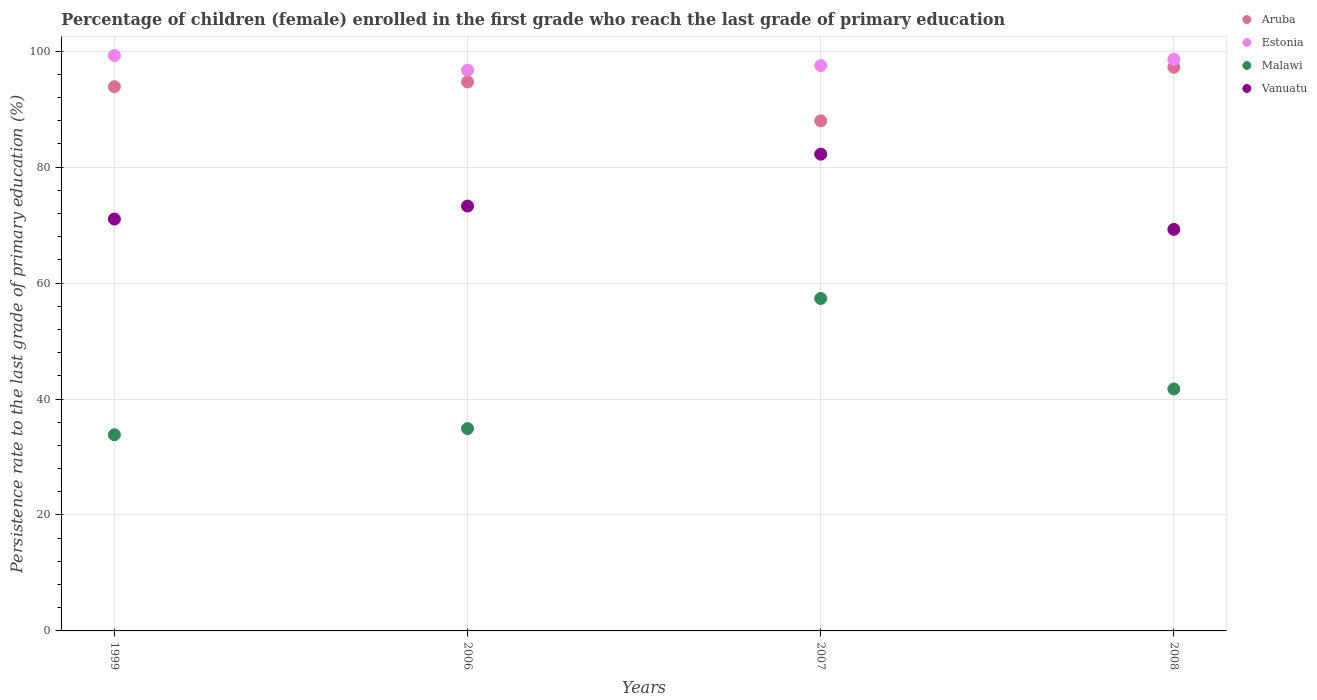What is the persistence rate of children in Estonia in 2006?
Make the answer very short. 96.73. Across all years, what is the maximum persistence rate of children in Aruba?
Give a very brief answer. 97.23. Across all years, what is the minimum persistence rate of children in Malawi?
Provide a succinct answer. 33.84. What is the total persistence rate of children in Aruba in the graph?
Offer a very short reply. 373.79. What is the difference between the persistence rate of children in Vanuatu in 2007 and that in 2008?
Provide a succinct answer. 12.98. What is the difference between the persistence rate of children in Malawi in 1999 and the persistence rate of children in Aruba in 2007?
Offer a terse response. -54.15. What is the average persistence rate of children in Estonia per year?
Ensure brevity in your answer.  98.03. In the year 2006, what is the difference between the persistence rate of children in Estonia and persistence rate of children in Malawi?
Keep it short and to the point. 61.83. In how many years, is the persistence rate of children in Estonia greater than 32 %?
Your answer should be compact. 4. What is the ratio of the persistence rate of children in Estonia in 2006 to that in 2007?
Provide a succinct answer. 0.99. Is the persistence rate of children in Vanuatu in 1999 less than that in 2007?
Keep it short and to the point. Yes. What is the difference between the highest and the second highest persistence rate of children in Malawi?
Ensure brevity in your answer.  15.61. What is the difference between the highest and the lowest persistence rate of children in Estonia?
Give a very brief answer. 2.52. In how many years, is the persistence rate of children in Malawi greater than the average persistence rate of children in Malawi taken over all years?
Provide a short and direct response. 1. Is the sum of the persistence rate of children in Aruba in 2007 and 2008 greater than the maximum persistence rate of children in Malawi across all years?
Provide a short and direct response. Yes. Is it the case that in every year, the sum of the persistence rate of children in Estonia and persistence rate of children in Vanuatu  is greater than the sum of persistence rate of children in Aruba and persistence rate of children in Malawi?
Provide a short and direct response. Yes. Is the persistence rate of children in Aruba strictly greater than the persistence rate of children in Estonia over the years?
Your answer should be compact. No. What is the difference between two consecutive major ticks on the Y-axis?
Offer a very short reply. 20. Does the graph contain any zero values?
Your answer should be compact. No. Where does the legend appear in the graph?
Offer a terse response. Top right. How are the legend labels stacked?
Your response must be concise. Vertical. What is the title of the graph?
Offer a very short reply. Percentage of children (female) enrolled in the first grade who reach the last grade of primary education. Does "Middle East & North Africa (developing only)" appear as one of the legend labels in the graph?
Make the answer very short. No. What is the label or title of the Y-axis?
Ensure brevity in your answer.  Persistence rate to the last grade of primary education (%). What is the Persistence rate to the last grade of primary education (%) of Aruba in 1999?
Your response must be concise. 93.88. What is the Persistence rate to the last grade of primary education (%) of Estonia in 1999?
Ensure brevity in your answer.  99.25. What is the Persistence rate to the last grade of primary education (%) of Malawi in 1999?
Your answer should be compact. 33.84. What is the Persistence rate to the last grade of primary education (%) of Vanuatu in 1999?
Offer a terse response. 71.05. What is the Persistence rate to the last grade of primary education (%) in Aruba in 2006?
Make the answer very short. 94.7. What is the Persistence rate to the last grade of primary education (%) of Estonia in 2006?
Your answer should be very brief. 96.73. What is the Persistence rate to the last grade of primary education (%) of Malawi in 2006?
Your response must be concise. 34.9. What is the Persistence rate to the last grade of primary education (%) in Vanuatu in 2006?
Your answer should be very brief. 73.29. What is the Persistence rate to the last grade of primary education (%) in Aruba in 2007?
Your response must be concise. 87.99. What is the Persistence rate to the last grade of primary education (%) in Estonia in 2007?
Your answer should be very brief. 97.52. What is the Persistence rate to the last grade of primary education (%) of Malawi in 2007?
Ensure brevity in your answer.  57.35. What is the Persistence rate to the last grade of primary education (%) of Vanuatu in 2007?
Provide a short and direct response. 82.24. What is the Persistence rate to the last grade of primary education (%) in Aruba in 2008?
Offer a very short reply. 97.23. What is the Persistence rate to the last grade of primary education (%) in Estonia in 2008?
Offer a very short reply. 98.6. What is the Persistence rate to the last grade of primary education (%) in Malawi in 2008?
Your response must be concise. 41.74. What is the Persistence rate to the last grade of primary education (%) of Vanuatu in 2008?
Provide a short and direct response. 69.26. Across all years, what is the maximum Persistence rate to the last grade of primary education (%) in Aruba?
Give a very brief answer. 97.23. Across all years, what is the maximum Persistence rate to the last grade of primary education (%) of Estonia?
Offer a terse response. 99.25. Across all years, what is the maximum Persistence rate to the last grade of primary education (%) of Malawi?
Keep it short and to the point. 57.35. Across all years, what is the maximum Persistence rate to the last grade of primary education (%) in Vanuatu?
Your response must be concise. 82.24. Across all years, what is the minimum Persistence rate to the last grade of primary education (%) in Aruba?
Offer a very short reply. 87.99. Across all years, what is the minimum Persistence rate to the last grade of primary education (%) in Estonia?
Your answer should be very brief. 96.73. Across all years, what is the minimum Persistence rate to the last grade of primary education (%) of Malawi?
Provide a short and direct response. 33.84. Across all years, what is the minimum Persistence rate to the last grade of primary education (%) of Vanuatu?
Ensure brevity in your answer.  69.26. What is the total Persistence rate to the last grade of primary education (%) in Aruba in the graph?
Offer a very short reply. 373.79. What is the total Persistence rate to the last grade of primary education (%) of Estonia in the graph?
Provide a succinct answer. 392.11. What is the total Persistence rate to the last grade of primary education (%) of Malawi in the graph?
Provide a succinct answer. 167.82. What is the total Persistence rate to the last grade of primary education (%) of Vanuatu in the graph?
Ensure brevity in your answer.  295.84. What is the difference between the Persistence rate to the last grade of primary education (%) in Aruba in 1999 and that in 2006?
Provide a succinct answer. -0.82. What is the difference between the Persistence rate to the last grade of primary education (%) of Estonia in 1999 and that in 2006?
Provide a succinct answer. 2.52. What is the difference between the Persistence rate to the last grade of primary education (%) in Malawi in 1999 and that in 2006?
Offer a terse response. -1.06. What is the difference between the Persistence rate to the last grade of primary education (%) in Vanuatu in 1999 and that in 2006?
Offer a very short reply. -2.25. What is the difference between the Persistence rate to the last grade of primary education (%) in Aruba in 1999 and that in 2007?
Offer a very short reply. 5.89. What is the difference between the Persistence rate to the last grade of primary education (%) of Estonia in 1999 and that in 2007?
Keep it short and to the point. 1.73. What is the difference between the Persistence rate to the last grade of primary education (%) of Malawi in 1999 and that in 2007?
Ensure brevity in your answer.  -23.51. What is the difference between the Persistence rate to the last grade of primary education (%) of Vanuatu in 1999 and that in 2007?
Provide a succinct answer. -11.19. What is the difference between the Persistence rate to the last grade of primary education (%) in Aruba in 1999 and that in 2008?
Give a very brief answer. -3.35. What is the difference between the Persistence rate to the last grade of primary education (%) of Estonia in 1999 and that in 2008?
Your response must be concise. 0.65. What is the difference between the Persistence rate to the last grade of primary education (%) in Vanuatu in 1999 and that in 2008?
Your answer should be very brief. 1.79. What is the difference between the Persistence rate to the last grade of primary education (%) in Aruba in 2006 and that in 2007?
Give a very brief answer. 6.71. What is the difference between the Persistence rate to the last grade of primary education (%) in Estonia in 2006 and that in 2007?
Your answer should be very brief. -0.79. What is the difference between the Persistence rate to the last grade of primary education (%) of Malawi in 2006 and that in 2007?
Give a very brief answer. -22.45. What is the difference between the Persistence rate to the last grade of primary education (%) of Vanuatu in 2006 and that in 2007?
Keep it short and to the point. -8.94. What is the difference between the Persistence rate to the last grade of primary education (%) of Aruba in 2006 and that in 2008?
Provide a short and direct response. -2.54. What is the difference between the Persistence rate to the last grade of primary education (%) of Estonia in 2006 and that in 2008?
Your response must be concise. -1.87. What is the difference between the Persistence rate to the last grade of primary education (%) in Malawi in 2006 and that in 2008?
Your answer should be very brief. -6.84. What is the difference between the Persistence rate to the last grade of primary education (%) in Vanuatu in 2006 and that in 2008?
Keep it short and to the point. 4.03. What is the difference between the Persistence rate to the last grade of primary education (%) in Aruba in 2007 and that in 2008?
Provide a succinct answer. -9.24. What is the difference between the Persistence rate to the last grade of primary education (%) of Estonia in 2007 and that in 2008?
Make the answer very short. -1.08. What is the difference between the Persistence rate to the last grade of primary education (%) of Malawi in 2007 and that in 2008?
Give a very brief answer. 15.61. What is the difference between the Persistence rate to the last grade of primary education (%) in Vanuatu in 2007 and that in 2008?
Provide a succinct answer. 12.98. What is the difference between the Persistence rate to the last grade of primary education (%) in Aruba in 1999 and the Persistence rate to the last grade of primary education (%) in Estonia in 2006?
Make the answer very short. -2.85. What is the difference between the Persistence rate to the last grade of primary education (%) of Aruba in 1999 and the Persistence rate to the last grade of primary education (%) of Malawi in 2006?
Your response must be concise. 58.98. What is the difference between the Persistence rate to the last grade of primary education (%) in Aruba in 1999 and the Persistence rate to the last grade of primary education (%) in Vanuatu in 2006?
Your answer should be compact. 20.58. What is the difference between the Persistence rate to the last grade of primary education (%) of Estonia in 1999 and the Persistence rate to the last grade of primary education (%) of Malawi in 2006?
Your response must be concise. 64.35. What is the difference between the Persistence rate to the last grade of primary education (%) of Estonia in 1999 and the Persistence rate to the last grade of primary education (%) of Vanuatu in 2006?
Offer a very short reply. 25.96. What is the difference between the Persistence rate to the last grade of primary education (%) in Malawi in 1999 and the Persistence rate to the last grade of primary education (%) in Vanuatu in 2006?
Ensure brevity in your answer.  -39.46. What is the difference between the Persistence rate to the last grade of primary education (%) of Aruba in 1999 and the Persistence rate to the last grade of primary education (%) of Estonia in 2007?
Give a very brief answer. -3.65. What is the difference between the Persistence rate to the last grade of primary education (%) of Aruba in 1999 and the Persistence rate to the last grade of primary education (%) of Malawi in 2007?
Offer a terse response. 36.53. What is the difference between the Persistence rate to the last grade of primary education (%) in Aruba in 1999 and the Persistence rate to the last grade of primary education (%) in Vanuatu in 2007?
Your answer should be compact. 11.64. What is the difference between the Persistence rate to the last grade of primary education (%) of Estonia in 1999 and the Persistence rate to the last grade of primary education (%) of Malawi in 2007?
Keep it short and to the point. 41.9. What is the difference between the Persistence rate to the last grade of primary education (%) in Estonia in 1999 and the Persistence rate to the last grade of primary education (%) in Vanuatu in 2007?
Provide a short and direct response. 17.02. What is the difference between the Persistence rate to the last grade of primary education (%) in Malawi in 1999 and the Persistence rate to the last grade of primary education (%) in Vanuatu in 2007?
Provide a succinct answer. -48.4. What is the difference between the Persistence rate to the last grade of primary education (%) of Aruba in 1999 and the Persistence rate to the last grade of primary education (%) of Estonia in 2008?
Ensure brevity in your answer.  -4.72. What is the difference between the Persistence rate to the last grade of primary education (%) in Aruba in 1999 and the Persistence rate to the last grade of primary education (%) in Malawi in 2008?
Offer a very short reply. 52.14. What is the difference between the Persistence rate to the last grade of primary education (%) in Aruba in 1999 and the Persistence rate to the last grade of primary education (%) in Vanuatu in 2008?
Give a very brief answer. 24.61. What is the difference between the Persistence rate to the last grade of primary education (%) of Estonia in 1999 and the Persistence rate to the last grade of primary education (%) of Malawi in 2008?
Give a very brief answer. 57.52. What is the difference between the Persistence rate to the last grade of primary education (%) of Estonia in 1999 and the Persistence rate to the last grade of primary education (%) of Vanuatu in 2008?
Your response must be concise. 29.99. What is the difference between the Persistence rate to the last grade of primary education (%) of Malawi in 1999 and the Persistence rate to the last grade of primary education (%) of Vanuatu in 2008?
Your answer should be very brief. -35.43. What is the difference between the Persistence rate to the last grade of primary education (%) in Aruba in 2006 and the Persistence rate to the last grade of primary education (%) in Estonia in 2007?
Your answer should be very brief. -2.83. What is the difference between the Persistence rate to the last grade of primary education (%) of Aruba in 2006 and the Persistence rate to the last grade of primary education (%) of Malawi in 2007?
Offer a very short reply. 37.35. What is the difference between the Persistence rate to the last grade of primary education (%) of Aruba in 2006 and the Persistence rate to the last grade of primary education (%) of Vanuatu in 2007?
Your answer should be very brief. 12.46. What is the difference between the Persistence rate to the last grade of primary education (%) in Estonia in 2006 and the Persistence rate to the last grade of primary education (%) in Malawi in 2007?
Ensure brevity in your answer.  39.38. What is the difference between the Persistence rate to the last grade of primary education (%) in Estonia in 2006 and the Persistence rate to the last grade of primary education (%) in Vanuatu in 2007?
Give a very brief answer. 14.49. What is the difference between the Persistence rate to the last grade of primary education (%) of Malawi in 2006 and the Persistence rate to the last grade of primary education (%) of Vanuatu in 2007?
Give a very brief answer. -47.34. What is the difference between the Persistence rate to the last grade of primary education (%) in Aruba in 2006 and the Persistence rate to the last grade of primary education (%) in Estonia in 2008?
Offer a very short reply. -3.91. What is the difference between the Persistence rate to the last grade of primary education (%) of Aruba in 2006 and the Persistence rate to the last grade of primary education (%) of Malawi in 2008?
Provide a succinct answer. 52.96. What is the difference between the Persistence rate to the last grade of primary education (%) in Aruba in 2006 and the Persistence rate to the last grade of primary education (%) in Vanuatu in 2008?
Keep it short and to the point. 25.43. What is the difference between the Persistence rate to the last grade of primary education (%) of Estonia in 2006 and the Persistence rate to the last grade of primary education (%) of Malawi in 2008?
Ensure brevity in your answer.  55. What is the difference between the Persistence rate to the last grade of primary education (%) of Estonia in 2006 and the Persistence rate to the last grade of primary education (%) of Vanuatu in 2008?
Make the answer very short. 27.47. What is the difference between the Persistence rate to the last grade of primary education (%) of Malawi in 2006 and the Persistence rate to the last grade of primary education (%) of Vanuatu in 2008?
Make the answer very short. -34.36. What is the difference between the Persistence rate to the last grade of primary education (%) of Aruba in 2007 and the Persistence rate to the last grade of primary education (%) of Estonia in 2008?
Offer a very short reply. -10.61. What is the difference between the Persistence rate to the last grade of primary education (%) of Aruba in 2007 and the Persistence rate to the last grade of primary education (%) of Malawi in 2008?
Give a very brief answer. 46.25. What is the difference between the Persistence rate to the last grade of primary education (%) in Aruba in 2007 and the Persistence rate to the last grade of primary education (%) in Vanuatu in 2008?
Offer a very short reply. 18.73. What is the difference between the Persistence rate to the last grade of primary education (%) in Estonia in 2007 and the Persistence rate to the last grade of primary education (%) in Malawi in 2008?
Offer a terse response. 55.79. What is the difference between the Persistence rate to the last grade of primary education (%) of Estonia in 2007 and the Persistence rate to the last grade of primary education (%) of Vanuatu in 2008?
Ensure brevity in your answer.  28.26. What is the difference between the Persistence rate to the last grade of primary education (%) of Malawi in 2007 and the Persistence rate to the last grade of primary education (%) of Vanuatu in 2008?
Offer a very short reply. -11.91. What is the average Persistence rate to the last grade of primary education (%) of Aruba per year?
Your answer should be compact. 93.45. What is the average Persistence rate to the last grade of primary education (%) of Estonia per year?
Your response must be concise. 98.03. What is the average Persistence rate to the last grade of primary education (%) in Malawi per year?
Provide a succinct answer. 41.95. What is the average Persistence rate to the last grade of primary education (%) of Vanuatu per year?
Offer a terse response. 73.96. In the year 1999, what is the difference between the Persistence rate to the last grade of primary education (%) in Aruba and Persistence rate to the last grade of primary education (%) in Estonia?
Provide a succinct answer. -5.38. In the year 1999, what is the difference between the Persistence rate to the last grade of primary education (%) of Aruba and Persistence rate to the last grade of primary education (%) of Malawi?
Give a very brief answer. 60.04. In the year 1999, what is the difference between the Persistence rate to the last grade of primary education (%) of Aruba and Persistence rate to the last grade of primary education (%) of Vanuatu?
Your response must be concise. 22.83. In the year 1999, what is the difference between the Persistence rate to the last grade of primary education (%) in Estonia and Persistence rate to the last grade of primary education (%) in Malawi?
Offer a terse response. 65.42. In the year 1999, what is the difference between the Persistence rate to the last grade of primary education (%) in Estonia and Persistence rate to the last grade of primary education (%) in Vanuatu?
Offer a terse response. 28.2. In the year 1999, what is the difference between the Persistence rate to the last grade of primary education (%) in Malawi and Persistence rate to the last grade of primary education (%) in Vanuatu?
Provide a succinct answer. -37.21. In the year 2006, what is the difference between the Persistence rate to the last grade of primary education (%) of Aruba and Persistence rate to the last grade of primary education (%) of Estonia?
Make the answer very short. -2.04. In the year 2006, what is the difference between the Persistence rate to the last grade of primary education (%) in Aruba and Persistence rate to the last grade of primary education (%) in Malawi?
Your answer should be compact. 59.8. In the year 2006, what is the difference between the Persistence rate to the last grade of primary education (%) in Aruba and Persistence rate to the last grade of primary education (%) in Vanuatu?
Provide a succinct answer. 21.4. In the year 2006, what is the difference between the Persistence rate to the last grade of primary education (%) in Estonia and Persistence rate to the last grade of primary education (%) in Malawi?
Your answer should be compact. 61.83. In the year 2006, what is the difference between the Persistence rate to the last grade of primary education (%) in Estonia and Persistence rate to the last grade of primary education (%) in Vanuatu?
Your answer should be compact. 23.44. In the year 2006, what is the difference between the Persistence rate to the last grade of primary education (%) in Malawi and Persistence rate to the last grade of primary education (%) in Vanuatu?
Your answer should be very brief. -38.4. In the year 2007, what is the difference between the Persistence rate to the last grade of primary education (%) in Aruba and Persistence rate to the last grade of primary education (%) in Estonia?
Keep it short and to the point. -9.54. In the year 2007, what is the difference between the Persistence rate to the last grade of primary education (%) in Aruba and Persistence rate to the last grade of primary education (%) in Malawi?
Your answer should be compact. 30.64. In the year 2007, what is the difference between the Persistence rate to the last grade of primary education (%) in Aruba and Persistence rate to the last grade of primary education (%) in Vanuatu?
Your answer should be very brief. 5.75. In the year 2007, what is the difference between the Persistence rate to the last grade of primary education (%) of Estonia and Persistence rate to the last grade of primary education (%) of Malawi?
Keep it short and to the point. 40.18. In the year 2007, what is the difference between the Persistence rate to the last grade of primary education (%) in Estonia and Persistence rate to the last grade of primary education (%) in Vanuatu?
Offer a terse response. 15.29. In the year 2007, what is the difference between the Persistence rate to the last grade of primary education (%) in Malawi and Persistence rate to the last grade of primary education (%) in Vanuatu?
Give a very brief answer. -24.89. In the year 2008, what is the difference between the Persistence rate to the last grade of primary education (%) in Aruba and Persistence rate to the last grade of primary education (%) in Estonia?
Your answer should be compact. -1.37. In the year 2008, what is the difference between the Persistence rate to the last grade of primary education (%) in Aruba and Persistence rate to the last grade of primary education (%) in Malawi?
Ensure brevity in your answer.  55.5. In the year 2008, what is the difference between the Persistence rate to the last grade of primary education (%) in Aruba and Persistence rate to the last grade of primary education (%) in Vanuatu?
Keep it short and to the point. 27.97. In the year 2008, what is the difference between the Persistence rate to the last grade of primary education (%) of Estonia and Persistence rate to the last grade of primary education (%) of Malawi?
Ensure brevity in your answer.  56.87. In the year 2008, what is the difference between the Persistence rate to the last grade of primary education (%) of Estonia and Persistence rate to the last grade of primary education (%) of Vanuatu?
Make the answer very short. 29.34. In the year 2008, what is the difference between the Persistence rate to the last grade of primary education (%) of Malawi and Persistence rate to the last grade of primary education (%) of Vanuatu?
Provide a short and direct response. -27.53. What is the ratio of the Persistence rate to the last grade of primary education (%) in Estonia in 1999 to that in 2006?
Offer a very short reply. 1.03. What is the ratio of the Persistence rate to the last grade of primary education (%) in Malawi in 1999 to that in 2006?
Provide a succinct answer. 0.97. What is the ratio of the Persistence rate to the last grade of primary education (%) of Vanuatu in 1999 to that in 2006?
Make the answer very short. 0.97. What is the ratio of the Persistence rate to the last grade of primary education (%) in Aruba in 1999 to that in 2007?
Your response must be concise. 1.07. What is the ratio of the Persistence rate to the last grade of primary education (%) in Estonia in 1999 to that in 2007?
Give a very brief answer. 1.02. What is the ratio of the Persistence rate to the last grade of primary education (%) in Malawi in 1999 to that in 2007?
Give a very brief answer. 0.59. What is the ratio of the Persistence rate to the last grade of primary education (%) in Vanuatu in 1999 to that in 2007?
Offer a terse response. 0.86. What is the ratio of the Persistence rate to the last grade of primary education (%) of Aruba in 1999 to that in 2008?
Keep it short and to the point. 0.97. What is the ratio of the Persistence rate to the last grade of primary education (%) in Estonia in 1999 to that in 2008?
Your response must be concise. 1.01. What is the ratio of the Persistence rate to the last grade of primary education (%) of Malawi in 1999 to that in 2008?
Your answer should be very brief. 0.81. What is the ratio of the Persistence rate to the last grade of primary education (%) of Vanuatu in 1999 to that in 2008?
Provide a short and direct response. 1.03. What is the ratio of the Persistence rate to the last grade of primary education (%) in Aruba in 2006 to that in 2007?
Offer a terse response. 1.08. What is the ratio of the Persistence rate to the last grade of primary education (%) of Estonia in 2006 to that in 2007?
Offer a terse response. 0.99. What is the ratio of the Persistence rate to the last grade of primary education (%) of Malawi in 2006 to that in 2007?
Provide a short and direct response. 0.61. What is the ratio of the Persistence rate to the last grade of primary education (%) of Vanuatu in 2006 to that in 2007?
Provide a succinct answer. 0.89. What is the ratio of the Persistence rate to the last grade of primary education (%) of Aruba in 2006 to that in 2008?
Your answer should be compact. 0.97. What is the ratio of the Persistence rate to the last grade of primary education (%) in Malawi in 2006 to that in 2008?
Ensure brevity in your answer.  0.84. What is the ratio of the Persistence rate to the last grade of primary education (%) of Vanuatu in 2006 to that in 2008?
Ensure brevity in your answer.  1.06. What is the ratio of the Persistence rate to the last grade of primary education (%) in Aruba in 2007 to that in 2008?
Your answer should be compact. 0.9. What is the ratio of the Persistence rate to the last grade of primary education (%) in Estonia in 2007 to that in 2008?
Ensure brevity in your answer.  0.99. What is the ratio of the Persistence rate to the last grade of primary education (%) in Malawi in 2007 to that in 2008?
Provide a succinct answer. 1.37. What is the ratio of the Persistence rate to the last grade of primary education (%) of Vanuatu in 2007 to that in 2008?
Provide a succinct answer. 1.19. What is the difference between the highest and the second highest Persistence rate to the last grade of primary education (%) of Aruba?
Provide a succinct answer. 2.54. What is the difference between the highest and the second highest Persistence rate to the last grade of primary education (%) in Estonia?
Your response must be concise. 0.65. What is the difference between the highest and the second highest Persistence rate to the last grade of primary education (%) of Malawi?
Make the answer very short. 15.61. What is the difference between the highest and the second highest Persistence rate to the last grade of primary education (%) in Vanuatu?
Give a very brief answer. 8.94. What is the difference between the highest and the lowest Persistence rate to the last grade of primary education (%) in Aruba?
Your response must be concise. 9.24. What is the difference between the highest and the lowest Persistence rate to the last grade of primary education (%) of Estonia?
Provide a short and direct response. 2.52. What is the difference between the highest and the lowest Persistence rate to the last grade of primary education (%) in Malawi?
Provide a short and direct response. 23.51. What is the difference between the highest and the lowest Persistence rate to the last grade of primary education (%) in Vanuatu?
Offer a very short reply. 12.98. 